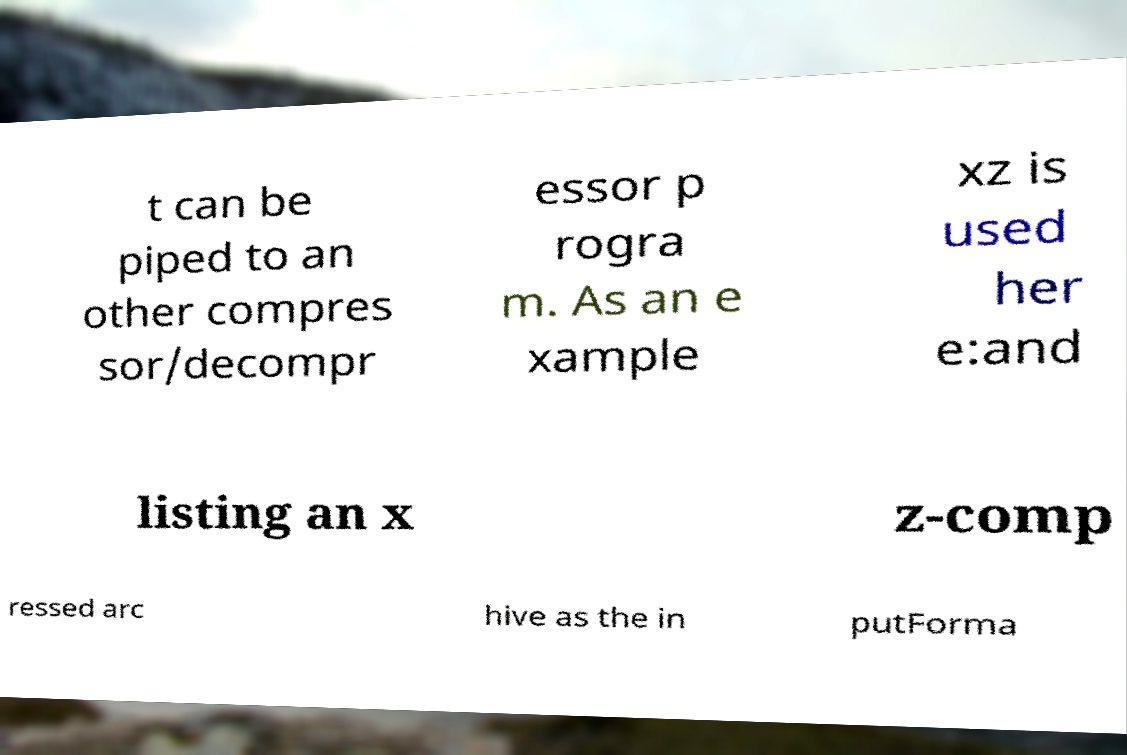I need the written content from this picture converted into text. Can you do that? t can be piped to an other compres sor/decompr essor p rogra m. As an e xample xz is used her e:and listing an x z-comp ressed arc hive as the in putForma 